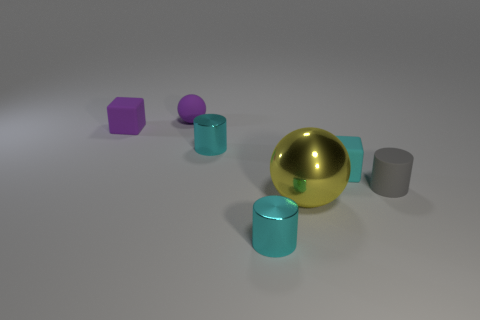Subtract all cyan cylinders. How many cylinders are left? 1 Add 2 brown blocks. How many objects exist? 9 Subtract all red balls. How many cyan cylinders are left? 2 Subtract all purple blocks. How many blocks are left? 1 Subtract 1 blocks. How many blocks are left? 1 Subtract all cubes. How many objects are left? 5 Subtract all yellow balls. Subtract all yellow cylinders. How many balls are left? 1 Subtract all purple rubber balls. Subtract all cyan matte blocks. How many objects are left? 5 Add 4 gray matte things. How many gray matte things are left? 5 Add 4 purple objects. How many purple objects exist? 6 